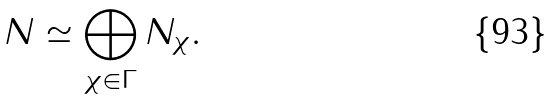Convert formula to latex. <formula><loc_0><loc_0><loc_500><loc_500>N \simeq \bigoplus _ { \chi \in \Gamma } N _ { \chi } .</formula> 